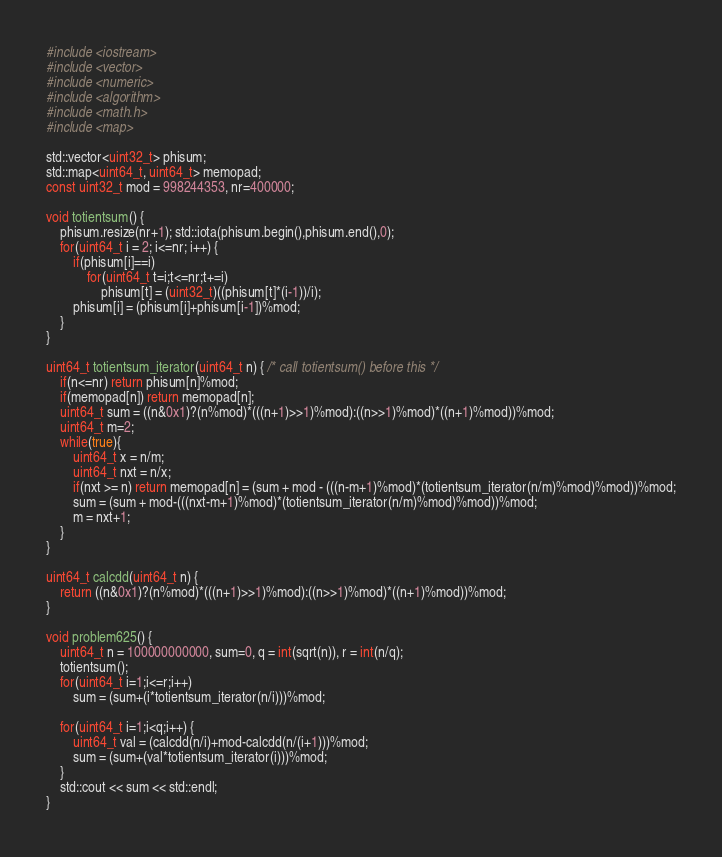<code> <loc_0><loc_0><loc_500><loc_500><_C++_>#include <iostream>
#include <vector>
#include <numeric>
#include <algorithm>
#include <math.h>
#include <map>

std::vector<uint32_t> phisum;
std::map<uint64_t, uint64_t> memopad;
const uint32_t mod = 998244353, nr=400000;

void totientsum() {
    phisum.resize(nr+1); std::iota(phisum.begin(),phisum.end(),0);
    for(uint64_t i = 2; i<=nr; i++) {
        if(phisum[i]==i)
            for(uint64_t t=i;t<=nr;t+=i)
                phisum[t] = (uint32_t)((phisum[t]*(i-1))/i);
        phisum[i] = (phisum[i]+phisum[i-1])%mod;
    }
}

uint64_t totientsum_iterator(uint64_t n) { /* call totientsum() before this */
    if(n<=nr) return phisum[n]%mod;
    if(memopad[n]) return memopad[n];
    uint64_t sum = ((n&0x1)?(n%mod)*(((n+1)>>1)%mod):((n>>1)%mod)*((n+1)%mod))%mod;
    uint64_t m=2;
    while(true){
        uint64_t x = n/m;
        uint64_t nxt = n/x;
        if(nxt >= n) return memopad[n] = (sum + mod - (((n-m+1)%mod)*(totientsum_iterator(n/m)%mod)%mod))%mod;
        sum = (sum + mod-(((nxt-m+1)%mod)*(totientsum_iterator(n/m)%mod)%mod))%mod;
        m = nxt+1;
    }
}

uint64_t calcdd(uint64_t n) {
    return ((n&0x1)?(n%mod)*(((n+1)>>1)%mod):((n>>1)%mod)*((n+1)%mod))%mod;
}

void problem625() {
    uint64_t n = 100000000000, sum=0, q = int(sqrt(n)), r = int(n/q);
    totientsum();
    for(uint64_t i=1;i<=r;i++)
        sum = (sum+(i*totientsum_iterator(n/i)))%mod;
    
    for(uint64_t i=1;i<q;i++) {
        uint64_t val = (calcdd(n/i)+mod-calcdd(n/(i+1)))%mod;
        sum = (sum+(val*totientsum_iterator(i)))%mod;
    }
    std::cout << sum << std::endl;
}</code> 